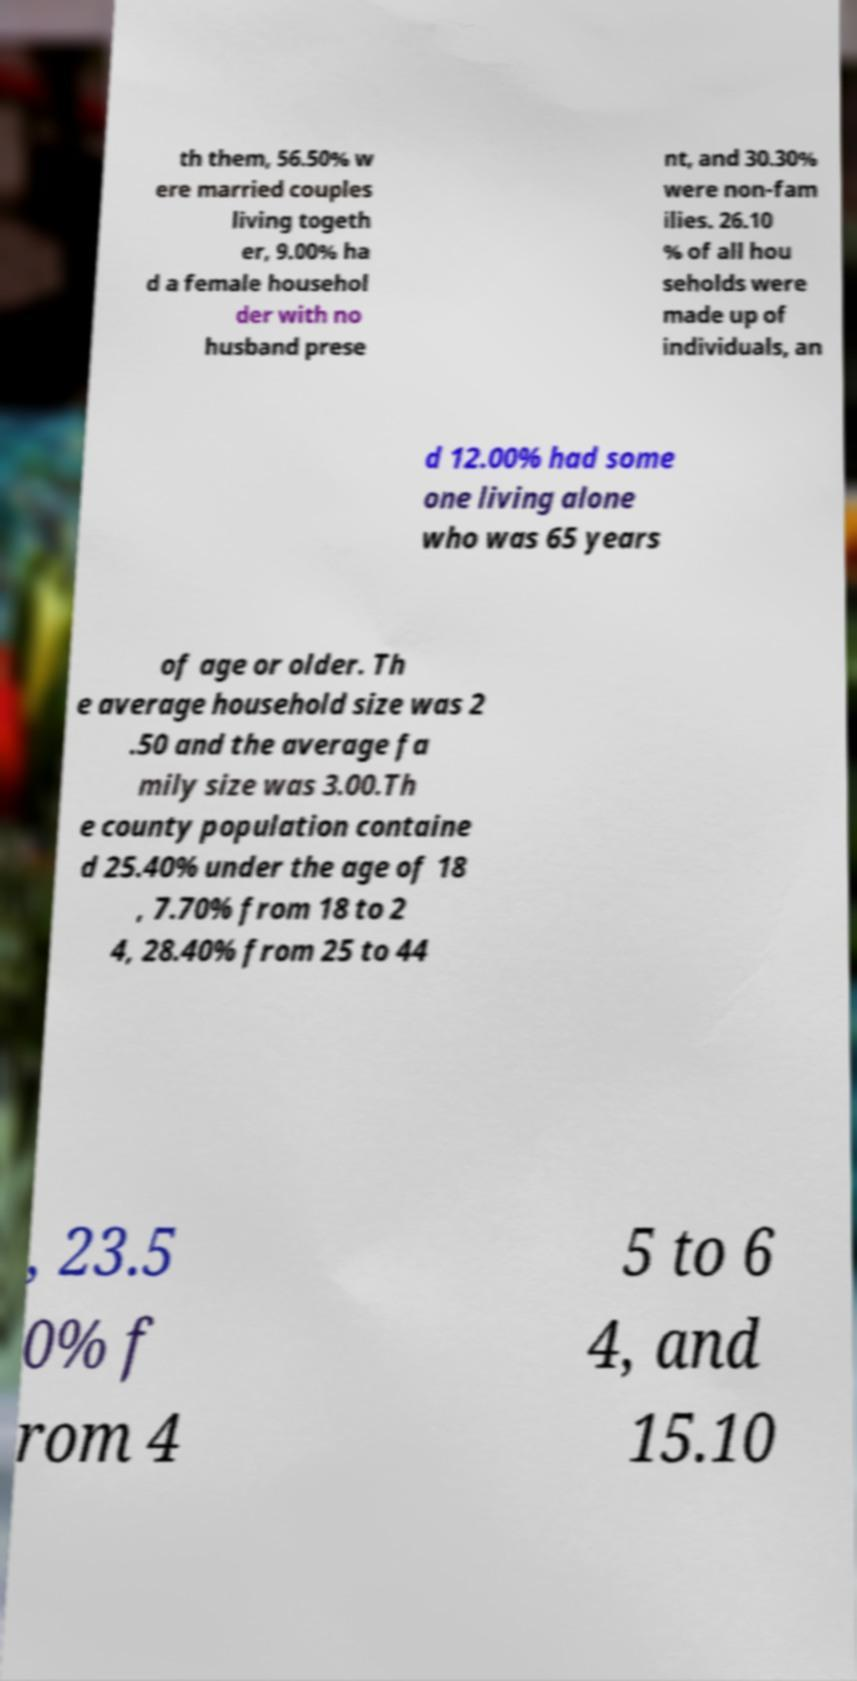Please identify and transcribe the text found in this image. th them, 56.50% w ere married couples living togeth er, 9.00% ha d a female househol der with no husband prese nt, and 30.30% were non-fam ilies. 26.10 % of all hou seholds were made up of individuals, an d 12.00% had some one living alone who was 65 years of age or older. Th e average household size was 2 .50 and the average fa mily size was 3.00.Th e county population containe d 25.40% under the age of 18 , 7.70% from 18 to 2 4, 28.40% from 25 to 44 , 23.5 0% f rom 4 5 to 6 4, and 15.10 